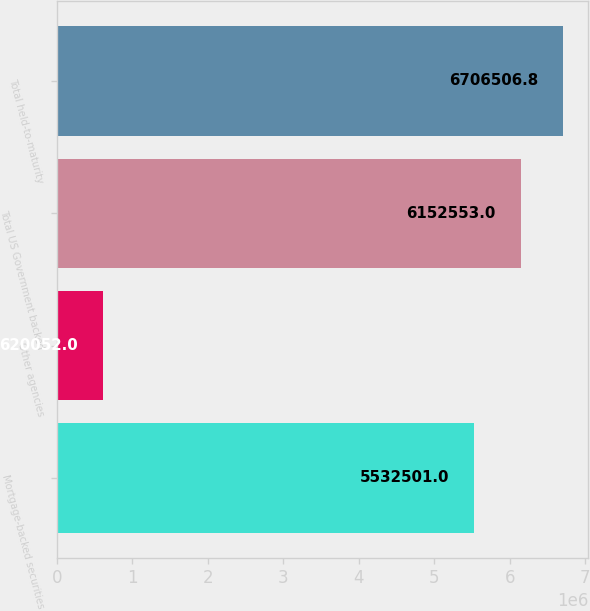Convert chart to OTSL. <chart><loc_0><loc_0><loc_500><loc_500><bar_chart><fcel>Mortgage-backed securities<fcel>Other agencies<fcel>Total US Government backed<fcel>Total held-to-maturity<nl><fcel>5.5325e+06<fcel>620052<fcel>6.15255e+06<fcel>6.70651e+06<nl></chart> 